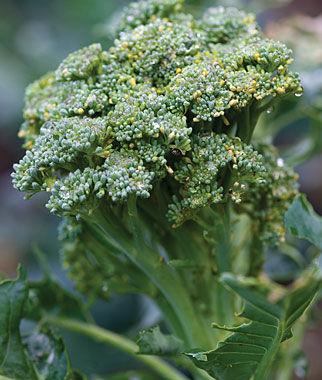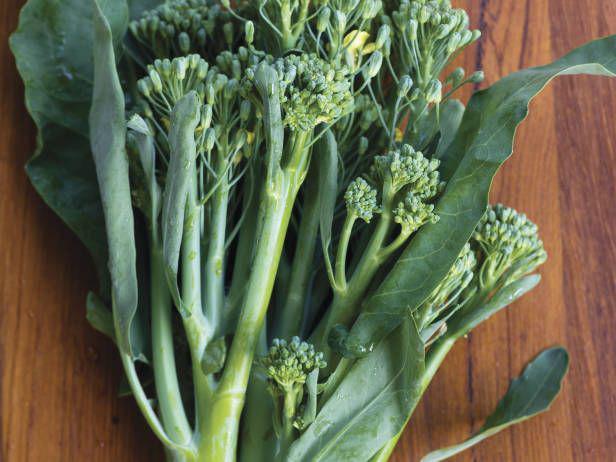The first image is the image on the left, the second image is the image on the right. Considering the images on both sides, is "The right image shows broccoli on a wooden surface." valid? Answer yes or no. Yes. 